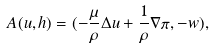<formula> <loc_0><loc_0><loc_500><loc_500>A ( u , h ) = ( - \frac { \mu } { \rho } \Delta u + \frac { 1 } { \rho } \nabla \pi , - w ) ,</formula> 